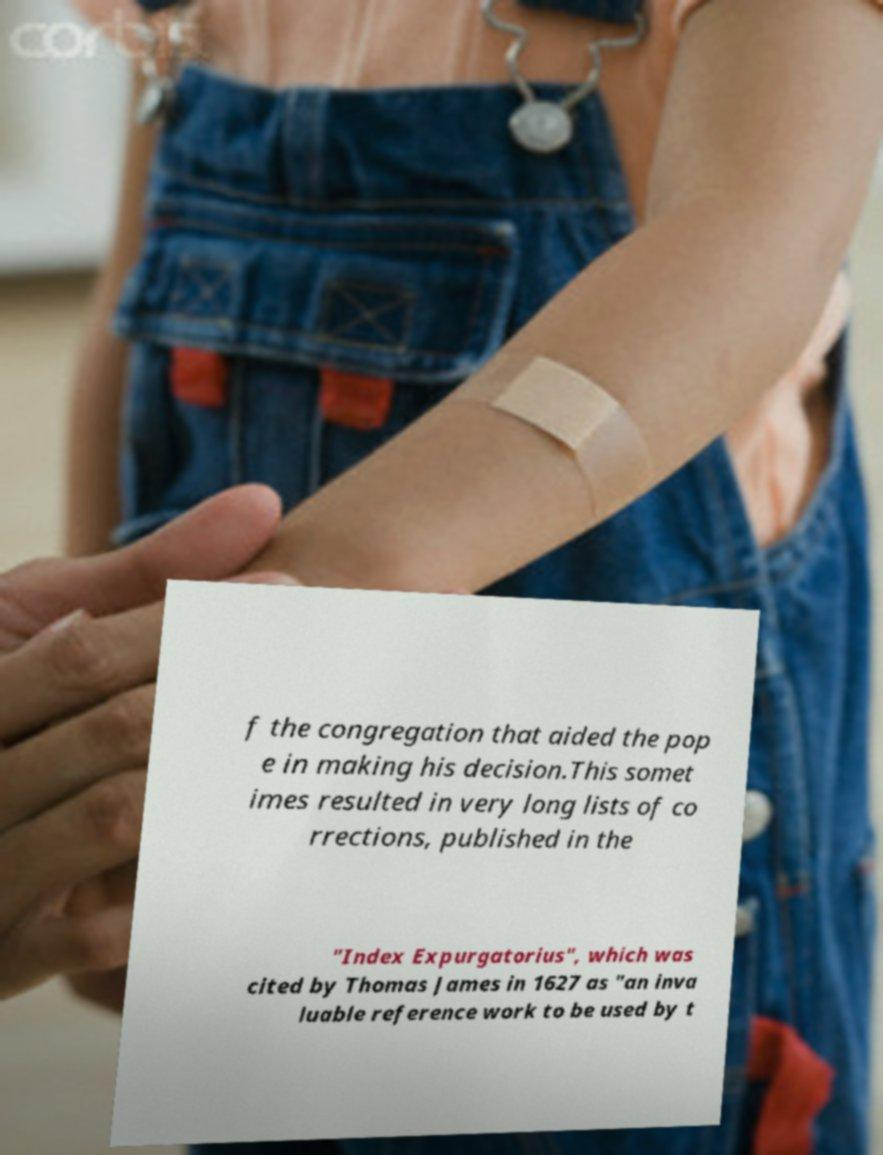Could you extract and type out the text from this image? f the congregation that aided the pop e in making his decision.This somet imes resulted in very long lists of co rrections, published in the "Index Expurgatorius", which was cited by Thomas James in 1627 as "an inva luable reference work to be used by t 